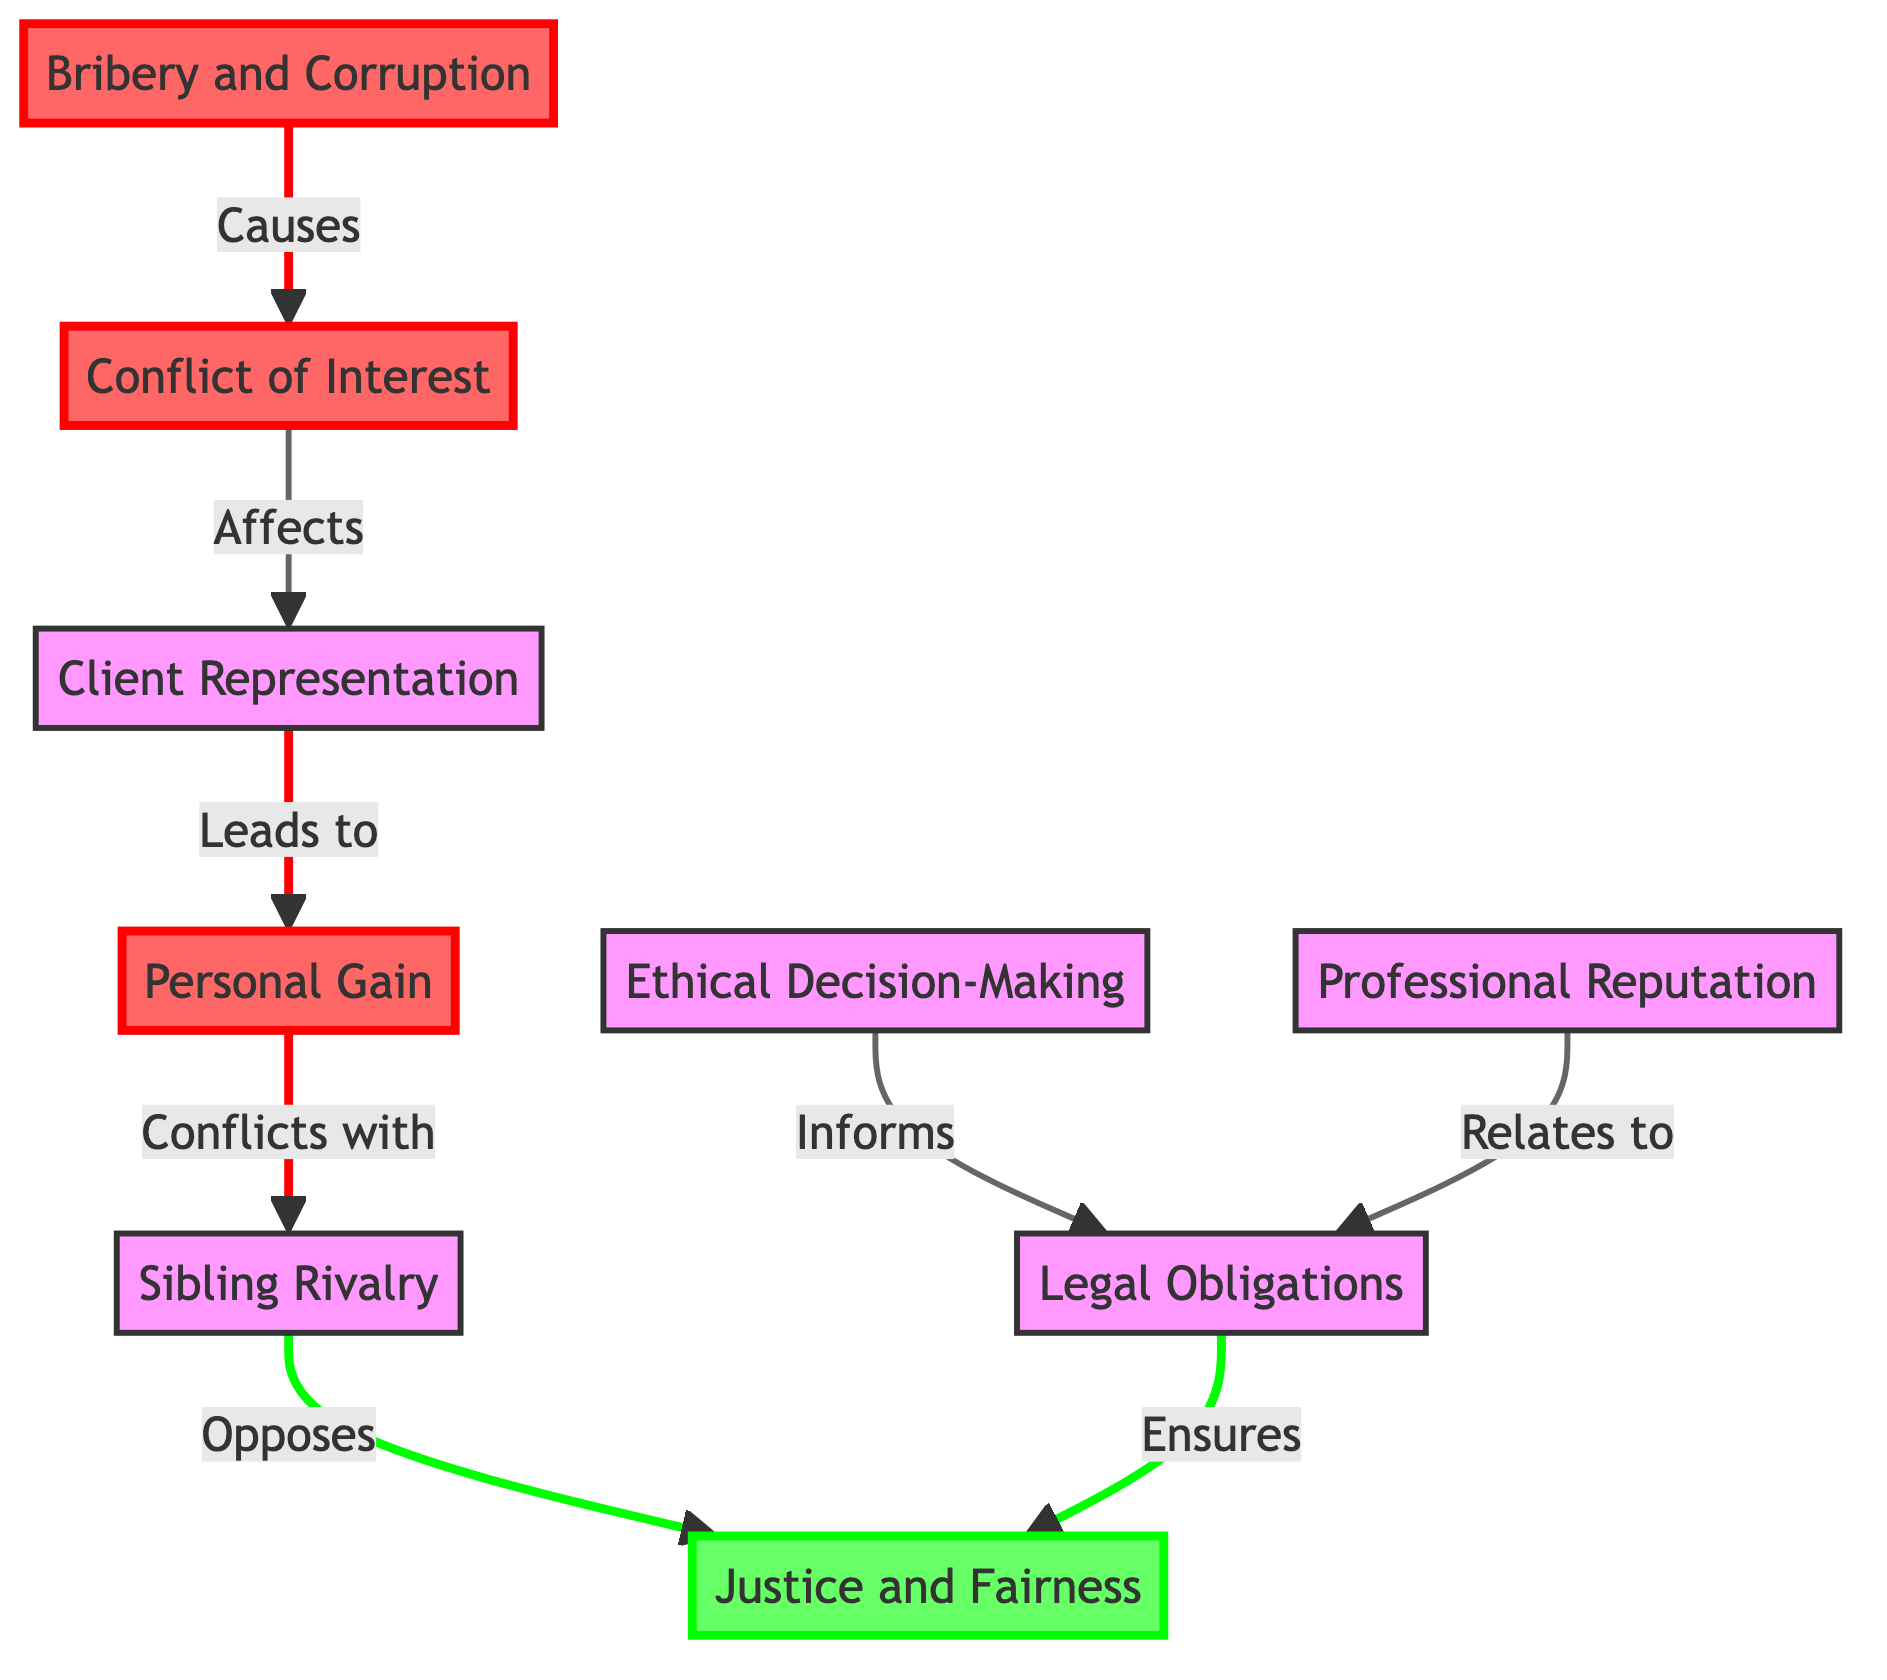What is the first node in the diagram? The first node in the diagram is labeled "Conflict of Interest." This is identified by checking the order in which the nodes are arranged, starting from the top.
Answer: Conflict of Interest How many nodes are in the diagram? By counting all the nodes, we find that there are nine distinct nodes depicted in the diagram, as each labeled item represents a unique node.
Answer: 9 What color represents ethical concepts in the diagram? The color representing ethical concepts in the diagram is green, which is used for the node labeled "Justice and Fairness." This can be determined by examining the color coding used in the diagram.
Answer: green Which node directly affects "Client Representation"? The node that directly affects "Client Representation" is "Conflict of Interest." This relationship is indicated by the directed arrow connecting the two nodes in the flowchart.
Answer: Conflict of Interest What does "Bribery and Corruption" cause? "Bribery and Corruption" causes "Conflict of Interest." This can be seen through the arrow labeled "Causes" leading from "Bribery and Corruption" to "Conflict of Interest."
Answer: Conflict of Interest What are the two opposing concepts shown in the diagram? The two opposing concepts shown in the diagram are "Sibling Rivalry" and "Justice and Fairness." Their opposition is indicated by the directed arrow between the two nodes.
Answer: Sibling Rivalry and Justice and Fairness How does "Ethical Decision-Making" relate to "Legal Obligations"? "Ethical Decision-Making" informs "Legal Obligations." This connection can be established by tracing the arrow labeled "Informs" from "Ethical Decision-Making" to "Legal Obligations."
Answer: informs Which node leads to personal gain in legal practice? The node that leads to "Personal Gain" is "Client Representation." The flow of information from "Client Representation" to "Personal Gain" is indicated by the arrow labeled "Leads to."
Answer: Client Representation How does "Professional Reputation" connect to "Justice and Fairness"? "Professional Reputation" connects to "Justice and Fairness" indirectly through "Legal Obligations," which ensures "Justice and Fairness." This involves tracing the connections in the diagram: "Professional Reputation" relates to "Legal Obligations," which in turn ensures "Justice and Fairness."
Answer: Ensures 